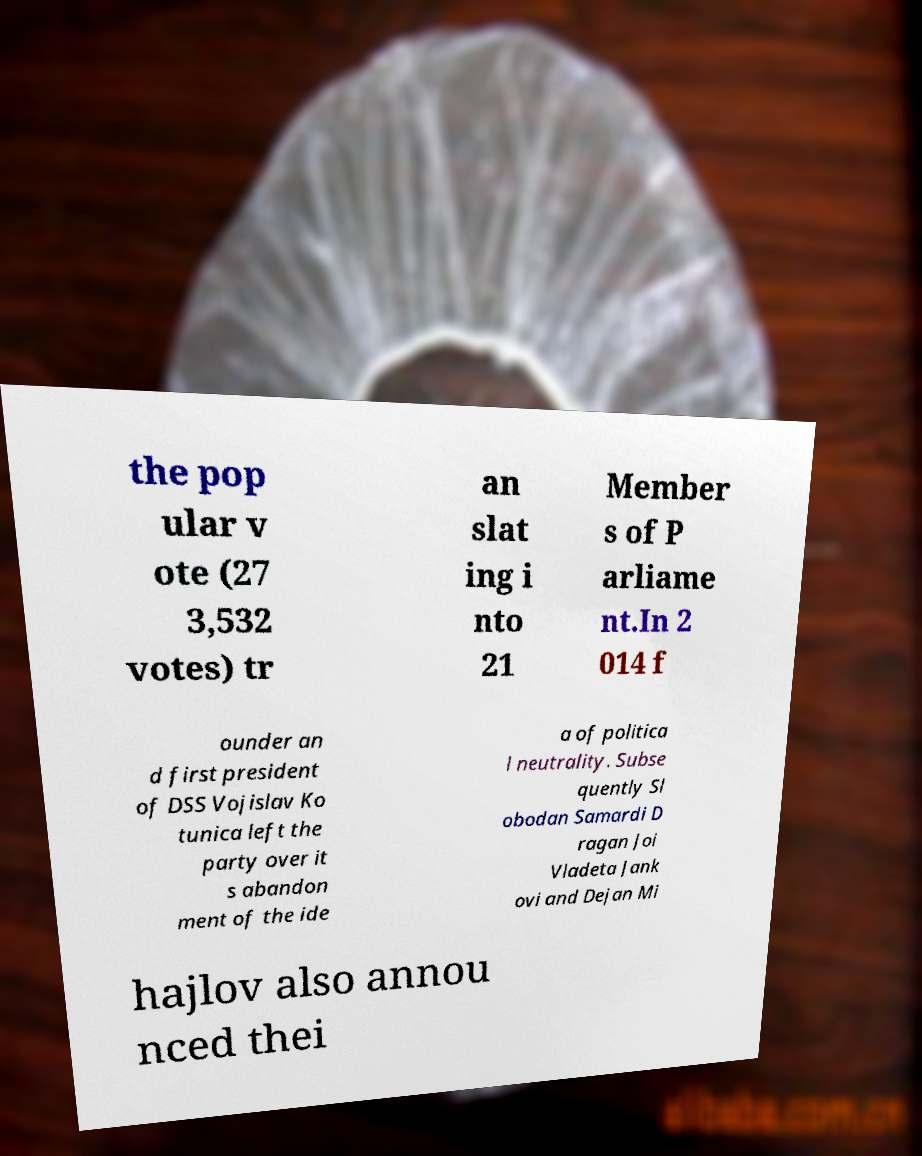Could you extract and type out the text from this image? the pop ular v ote (27 3,532 votes) tr an slat ing i nto 21 Member s of P arliame nt.In 2 014 f ounder an d first president of DSS Vojislav Ko tunica left the party over it s abandon ment of the ide a of politica l neutrality. Subse quently Sl obodan Samardi D ragan Joi Vladeta Jank ovi and Dejan Mi hajlov also annou nced thei 